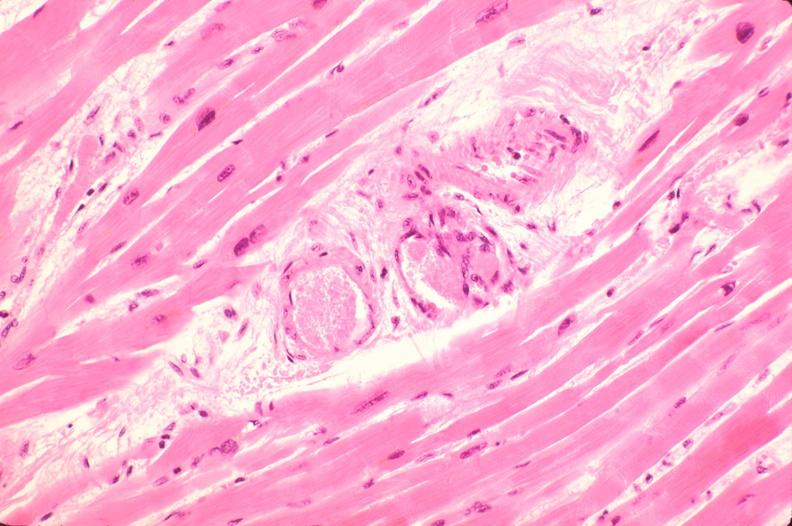what is present?
Answer the question using a single word or phrase. Cardiovascular 